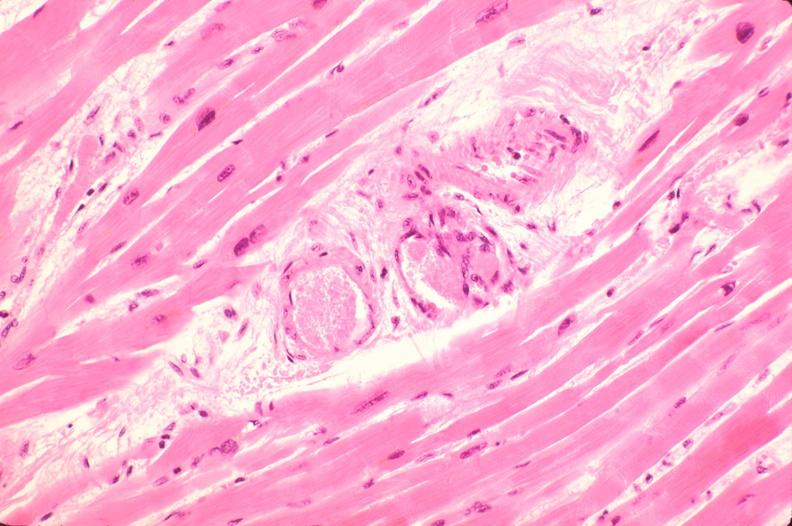what is present?
Answer the question using a single word or phrase. Cardiovascular 